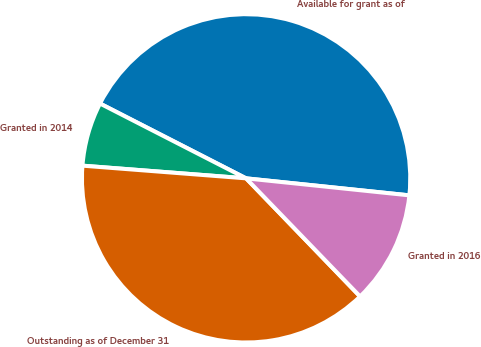Convert chart to OTSL. <chart><loc_0><loc_0><loc_500><loc_500><pie_chart><fcel>Available for grant as of<fcel>Granted in 2014<fcel>Outstanding as of December 31<fcel>Granted in 2016<nl><fcel>44.12%<fcel>6.3%<fcel>38.45%<fcel>11.13%<nl></chart> 